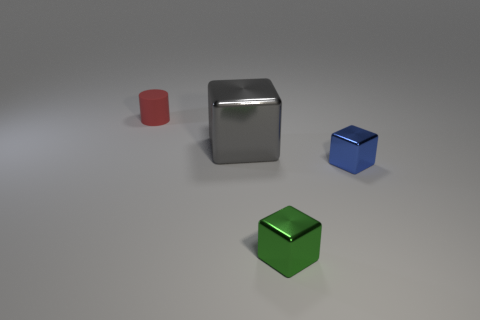Is there any other thing that has the same material as the red object?
Ensure brevity in your answer.  No. Are there any other things that are the same size as the gray thing?
Offer a very short reply. No. Is the shape of the thing in front of the blue cube the same as the thing on the left side of the gray shiny block?
Provide a succinct answer. No. The small shiny object left of the shiny thing that is to the right of the small thing that is in front of the blue shiny cube is what color?
Ensure brevity in your answer.  Green. What is the color of the thing that is to the left of the gray shiny thing?
Your answer should be very brief. Red. What is the color of the matte cylinder that is the same size as the green metal object?
Provide a short and direct response. Red. Is the size of the green shiny block the same as the blue metal cube?
Keep it short and to the point. Yes. There is a tiny blue cube; what number of cubes are in front of it?
Your answer should be compact. 1. How many things are tiny shiny blocks that are behind the tiny green metal thing or large cyan objects?
Give a very brief answer. 1. Is the number of blue things left of the red thing greater than the number of gray metallic objects behind the big block?
Offer a very short reply. No. 